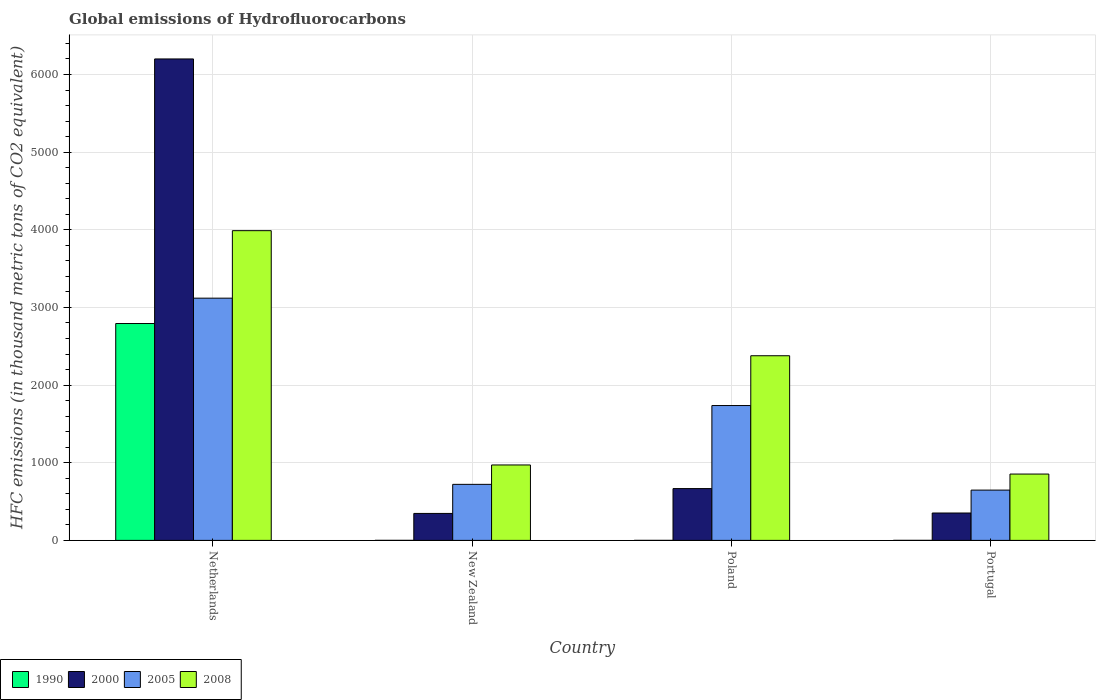How many groups of bars are there?
Ensure brevity in your answer.  4. Are the number of bars per tick equal to the number of legend labels?
Your response must be concise. Yes. Are the number of bars on each tick of the X-axis equal?
Make the answer very short. Yes. How many bars are there on the 1st tick from the left?
Give a very brief answer. 4. How many bars are there on the 4th tick from the right?
Keep it short and to the point. 4. What is the label of the 2nd group of bars from the left?
Provide a short and direct response. New Zealand. Across all countries, what is the maximum global emissions of Hydrofluorocarbons in 2005?
Ensure brevity in your answer.  3119.5. Across all countries, what is the minimum global emissions of Hydrofluorocarbons in 1990?
Keep it short and to the point. 0.1. In which country was the global emissions of Hydrofluorocarbons in 2005 maximum?
Offer a terse response. Netherlands. In which country was the global emissions of Hydrofluorocarbons in 1990 minimum?
Keep it short and to the point. Poland. What is the total global emissions of Hydrofluorocarbons in 2000 in the graph?
Ensure brevity in your answer.  7567.6. What is the difference between the global emissions of Hydrofluorocarbons in 2000 in Poland and that in Portugal?
Your answer should be compact. 314.5. What is the difference between the global emissions of Hydrofluorocarbons in 2008 in New Zealand and the global emissions of Hydrofluorocarbons in 1990 in Netherlands?
Provide a short and direct response. -1821.5. What is the average global emissions of Hydrofluorocarbons in 1990 per country?
Make the answer very short. 698.35. What is the difference between the global emissions of Hydrofluorocarbons of/in 2005 and global emissions of Hydrofluorocarbons of/in 2008 in Poland?
Give a very brief answer. -641.3. What is the ratio of the global emissions of Hydrofluorocarbons in 2005 in New Zealand to that in Portugal?
Offer a very short reply. 1.11. Is the difference between the global emissions of Hydrofluorocarbons in 2005 in New Zealand and Poland greater than the difference between the global emissions of Hydrofluorocarbons in 2008 in New Zealand and Poland?
Provide a succinct answer. Yes. What is the difference between the highest and the second highest global emissions of Hydrofluorocarbons in 2008?
Keep it short and to the point. 1406.6. What is the difference between the highest and the lowest global emissions of Hydrofluorocarbons in 1990?
Your answer should be very brief. 2792.8. Is it the case that in every country, the sum of the global emissions of Hydrofluorocarbons in 2008 and global emissions of Hydrofluorocarbons in 2000 is greater than the sum of global emissions of Hydrofluorocarbons in 1990 and global emissions of Hydrofluorocarbons in 2005?
Offer a very short reply. No. What does the 4th bar from the left in Netherlands represents?
Keep it short and to the point. 2008. Are the values on the major ticks of Y-axis written in scientific E-notation?
Your answer should be very brief. No. Does the graph contain any zero values?
Keep it short and to the point. No. How are the legend labels stacked?
Make the answer very short. Horizontal. What is the title of the graph?
Give a very brief answer. Global emissions of Hydrofluorocarbons. Does "1966" appear as one of the legend labels in the graph?
Offer a very short reply. No. What is the label or title of the X-axis?
Your response must be concise. Country. What is the label or title of the Y-axis?
Offer a very short reply. HFC emissions (in thousand metric tons of CO2 equivalent). What is the HFC emissions (in thousand metric tons of CO2 equivalent) of 1990 in Netherlands?
Keep it short and to the point. 2792.9. What is the HFC emissions (in thousand metric tons of CO2 equivalent) of 2000 in Netherlands?
Your response must be concise. 6200.4. What is the HFC emissions (in thousand metric tons of CO2 equivalent) of 2005 in Netherlands?
Offer a terse response. 3119.5. What is the HFC emissions (in thousand metric tons of CO2 equivalent) of 2008 in Netherlands?
Provide a succinct answer. 3988.8. What is the HFC emissions (in thousand metric tons of CO2 equivalent) in 2000 in New Zealand?
Provide a succinct answer. 347.3. What is the HFC emissions (in thousand metric tons of CO2 equivalent) of 2005 in New Zealand?
Offer a terse response. 721.7. What is the HFC emissions (in thousand metric tons of CO2 equivalent) of 2008 in New Zealand?
Your answer should be compact. 971.4. What is the HFC emissions (in thousand metric tons of CO2 equivalent) of 2000 in Poland?
Your response must be concise. 667.2. What is the HFC emissions (in thousand metric tons of CO2 equivalent) in 2005 in Poland?
Offer a very short reply. 1736.7. What is the HFC emissions (in thousand metric tons of CO2 equivalent) of 2008 in Poland?
Offer a very short reply. 2378. What is the HFC emissions (in thousand metric tons of CO2 equivalent) of 2000 in Portugal?
Your answer should be very brief. 352.7. What is the HFC emissions (in thousand metric tons of CO2 equivalent) in 2005 in Portugal?
Your answer should be compact. 647.7. What is the HFC emissions (in thousand metric tons of CO2 equivalent) in 2008 in Portugal?
Provide a short and direct response. 854.4. Across all countries, what is the maximum HFC emissions (in thousand metric tons of CO2 equivalent) of 1990?
Offer a terse response. 2792.9. Across all countries, what is the maximum HFC emissions (in thousand metric tons of CO2 equivalent) in 2000?
Your response must be concise. 6200.4. Across all countries, what is the maximum HFC emissions (in thousand metric tons of CO2 equivalent) in 2005?
Offer a very short reply. 3119.5. Across all countries, what is the maximum HFC emissions (in thousand metric tons of CO2 equivalent) in 2008?
Your response must be concise. 3988.8. Across all countries, what is the minimum HFC emissions (in thousand metric tons of CO2 equivalent) of 1990?
Provide a succinct answer. 0.1. Across all countries, what is the minimum HFC emissions (in thousand metric tons of CO2 equivalent) in 2000?
Your answer should be compact. 347.3. Across all countries, what is the minimum HFC emissions (in thousand metric tons of CO2 equivalent) of 2005?
Give a very brief answer. 647.7. Across all countries, what is the minimum HFC emissions (in thousand metric tons of CO2 equivalent) in 2008?
Provide a short and direct response. 854.4. What is the total HFC emissions (in thousand metric tons of CO2 equivalent) of 1990 in the graph?
Make the answer very short. 2793.4. What is the total HFC emissions (in thousand metric tons of CO2 equivalent) of 2000 in the graph?
Provide a succinct answer. 7567.6. What is the total HFC emissions (in thousand metric tons of CO2 equivalent) in 2005 in the graph?
Your response must be concise. 6225.6. What is the total HFC emissions (in thousand metric tons of CO2 equivalent) of 2008 in the graph?
Your answer should be very brief. 8192.6. What is the difference between the HFC emissions (in thousand metric tons of CO2 equivalent) of 1990 in Netherlands and that in New Zealand?
Make the answer very short. 2792.7. What is the difference between the HFC emissions (in thousand metric tons of CO2 equivalent) in 2000 in Netherlands and that in New Zealand?
Keep it short and to the point. 5853.1. What is the difference between the HFC emissions (in thousand metric tons of CO2 equivalent) of 2005 in Netherlands and that in New Zealand?
Your response must be concise. 2397.8. What is the difference between the HFC emissions (in thousand metric tons of CO2 equivalent) of 2008 in Netherlands and that in New Zealand?
Your response must be concise. 3017.4. What is the difference between the HFC emissions (in thousand metric tons of CO2 equivalent) of 1990 in Netherlands and that in Poland?
Offer a terse response. 2792.8. What is the difference between the HFC emissions (in thousand metric tons of CO2 equivalent) in 2000 in Netherlands and that in Poland?
Make the answer very short. 5533.2. What is the difference between the HFC emissions (in thousand metric tons of CO2 equivalent) in 2005 in Netherlands and that in Poland?
Your answer should be compact. 1382.8. What is the difference between the HFC emissions (in thousand metric tons of CO2 equivalent) in 2008 in Netherlands and that in Poland?
Offer a very short reply. 1610.8. What is the difference between the HFC emissions (in thousand metric tons of CO2 equivalent) in 1990 in Netherlands and that in Portugal?
Your answer should be very brief. 2792.7. What is the difference between the HFC emissions (in thousand metric tons of CO2 equivalent) of 2000 in Netherlands and that in Portugal?
Ensure brevity in your answer.  5847.7. What is the difference between the HFC emissions (in thousand metric tons of CO2 equivalent) in 2005 in Netherlands and that in Portugal?
Give a very brief answer. 2471.8. What is the difference between the HFC emissions (in thousand metric tons of CO2 equivalent) of 2008 in Netherlands and that in Portugal?
Give a very brief answer. 3134.4. What is the difference between the HFC emissions (in thousand metric tons of CO2 equivalent) in 2000 in New Zealand and that in Poland?
Your answer should be very brief. -319.9. What is the difference between the HFC emissions (in thousand metric tons of CO2 equivalent) in 2005 in New Zealand and that in Poland?
Keep it short and to the point. -1015. What is the difference between the HFC emissions (in thousand metric tons of CO2 equivalent) of 2008 in New Zealand and that in Poland?
Your answer should be very brief. -1406.6. What is the difference between the HFC emissions (in thousand metric tons of CO2 equivalent) of 1990 in New Zealand and that in Portugal?
Your response must be concise. 0. What is the difference between the HFC emissions (in thousand metric tons of CO2 equivalent) of 2000 in New Zealand and that in Portugal?
Your answer should be compact. -5.4. What is the difference between the HFC emissions (in thousand metric tons of CO2 equivalent) of 2008 in New Zealand and that in Portugal?
Provide a short and direct response. 117. What is the difference between the HFC emissions (in thousand metric tons of CO2 equivalent) of 2000 in Poland and that in Portugal?
Your response must be concise. 314.5. What is the difference between the HFC emissions (in thousand metric tons of CO2 equivalent) of 2005 in Poland and that in Portugal?
Your response must be concise. 1089. What is the difference between the HFC emissions (in thousand metric tons of CO2 equivalent) in 2008 in Poland and that in Portugal?
Keep it short and to the point. 1523.6. What is the difference between the HFC emissions (in thousand metric tons of CO2 equivalent) in 1990 in Netherlands and the HFC emissions (in thousand metric tons of CO2 equivalent) in 2000 in New Zealand?
Offer a very short reply. 2445.6. What is the difference between the HFC emissions (in thousand metric tons of CO2 equivalent) of 1990 in Netherlands and the HFC emissions (in thousand metric tons of CO2 equivalent) of 2005 in New Zealand?
Provide a succinct answer. 2071.2. What is the difference between the HFC emissions (in thousand metric tons of CO2 equivalent) of 1990 in Netherlands and the HFC emissions (in thousand metric tons of CO2 equivalent) of 2008 in New Zealand?
Keep it short and to the point. 1821.5. What is the difference between the HFC emissions (in thousand metric tons of CO2 equivalent) of 2000 in Netherlands and the HFC emissions (in thousand metric tons of CO2 equivalent) of 2005 in New Zealand?
Keep it short and to the point. 5478.7. What is the difference between the HFC emissions (in thousand metric tons of CO2 equivalent) of 2000 in Netherlands and the HFC emissions (in thousand metric tons of CO2 equivalent) of 2008 in New Zealand?
Your answer should be compact. 5229. What is the difference between the HFC emissions (in thousand metric tons of CO2 equivalent) of 2005 in Netherlands and the HFC emissions (in thousand metric tons of CO2 equivalent) of 2008 in New Zealand?
Ensure brevity in your answer.  2148.1. What is the difference between the HFC emissions (in thousand metric tons of CO2 equivalent) in 1990 in Netherlands and the HFC emissions (in thousand metric tons of CO2 equivalent) in 2000 in Poland?
Your response must be concise. 2125.7. What is the difference between the HFC emissions (in thousand metric tons of CO2 equivalent) of 1990 in Netherlands and the HFC emissions (in thousand metric tons of CO2 equivalent) of 2005 in Poland?
Give a very brief answer. 1056.2. What is the difference between the HFC emissions (in thousand metric tons of CO2 equivalent) in 1990 in Netherlands and the HFC emissions (in thousand metric tons of CO2 equivalent) in 2008 in Poland?
Your answer should be very brief. 414.9. What is the difference between the HFC emissions (in thousand metric tons of CO2 equivalent) of 2000 in Netherlands and the HFC emissions (in thousand metric tons of CO2 equivalent) of 2005 in Poland?
Keep it short and to the point. 4463.7. What is the difference between the HFC emissions (in thousand metric tons of CO2 equivalent) in 2000 in Netherlands and the HFC emissions (in thousand metric tons of CO2 equivalent) in 2008 in Poland?
Keep it short and to the point. 3822.4. What is the difference between the HFC emissions (in thousand metric tons of CO2 equivalent) of 2005 in Netherlands and the HFC emissions (in thousand metric tons of CO2 equivalent) of 2008 in Poland?
Offer a terse response. 741.5. What is the difference between the HFC emissions (in thousand metric tons of CO2 equivalent) of 1990 in Netherlands and the HFC emissions (in thousand metric tons of CO2 equivalent) of 2000 in Portugal?
Make the answer very short. 2440.2. What is the difference between the HFC emissions (in thousand metric tons of CO2 equivalent) in 1990 in Netherlands and the HFC emissions (in thousand metric tons of CO2 equivalent) in 2005 in Portugal?
Your answer should be very brief. 2145.2. What is the difference between the HFC emissions (in thousand metric tons of CO2 equivalent) of 1990 in Netherlands and the HFC emissions (in thousand metric tons of CO2 equivalent) of 2008 in Portugal?
Keep it short and to the point. 1938.5. What is the difference between the HFC emissions (in thousand metric tons of CO2 equivalent) in 2000 in Netherlands and the HFC emissions (in thousand metric tons of CO2 equivalent) in 2005 in Portugal?
Offer a terse response. 5552.7. What is the difference between the HFC emissions (in thousand metric tons of CO2 equivalent) in 2000 in Netherlands and the HFC emissions (in thousand metric tons of CO2 equivalent) in 2008 in Portugal?
Make the answer very short. 5346. What is the difference between the HFC emissions (in thousand metric tons of CO2 equivalent) in 2005 in Netherlands and the HFC emissions (in thousand metric tons of CO2 equivalent) in 2008 in Portugal?
Ensure brevity in your answer.  2265.1. What is the difference between the HFC emissions (in thousand metric tons of CO2 equivalent) in 1990 in New Zealand and the HFC emissions (in thousand metric tons of CO2 equivalent) in 2000 in Poland?
Provide a short and direct response. -667. What is the difference between the HFC emissions (in thousand metric tons of CO2 equivalent) of 1990 in New Zealand and the HFC emissions (in thousand metric tons of CO2 equivalent) of 2005 in Poland?
Provide a short and direct response. -1736.5. What is the difference between the HFC emissions (in thousand metric tons of CO2 equivalent) in 1990 in New Zealand and the HFC emissions (in thousand metric tons of CO2 equivalent) in 2008 in Poland?
Keep it short and to the point. -2377.8. What is the difference between the HFC emissions (in thousand metric tons of CO2 equivalent) of 2000 in New Zealand and the HFC emissions (in thousand metric tons of CO2 equivalent) of 2005 in Poland?
Make the answer very short. -1389.4. What is the difference between the HFC emissions (in thousand metric tons of CO2 equivalent) in 2000 in New Zealand and the HFC emissions (in thousand metric tons of CO2 equivalent) in 2008 in Poland?
Provide a short and direct response. -2030.7. What is the difference between the HFC emissions (in thousand metric tons of CO2 equivalent) of 2005 in New Zealand and the HFC emissions (in thousand metric tons of CO2 equivalent) of 2008 in Poland?
Keep it short and to the point. -1656.3. What is the difference between the HFC emissions (in thousand metric tons of CO2 equivalent) of 1990 in New Zealand and the HFC emissions (in thousand metric tons of CO2 equivalent) of 2000 in Portugal?
Ensure brevity in your answer.  -352.5. What is the difference between the HFC emissions (in thousand metric tons of CO2 equivalent) of 1990 in New Zealand and the HFC emissions (in thousand metric tons of CO2 equivalent) of 2005 in Portugal?
Provide a short and direct response. -647.5. What is the difference between the HFC emissions (in thousand metric tons of CO2 equivalent) in 1990 in New Zealand and the HFC emissions (in thousand metric tons of CO2 equivalent) in 2008 in Portugal?
Provide a succinct answer. -854.2. What is the difference between the HFC emissions (in thousand metric tons of CO2 equivalent) in 2000 in New Zealand and the HFC emissions (in thousand metric tons of CO2 equivalent) in 2005 in Portugal?
Offer a very short reply. -300.4. What is the difference between the HFC emissions (in thousand metric tons of CO2 equivalent) in 2000 in New Zealand and the HFC emissions (in thousand metric tons of CO2 equivalent) in 2008 in Portugal?
Give a very brief answer. -507.1. What is the difference between the HFC emissions (in thousand metric tons of CO2 equivalent) in 2005 in New Zealand and the HFC emissions (in thousand metric tons of CO2 equivalent) in 2008 in Portugal?
Give a very brief answer. -132.7. What is the difference between the HFC emissions (in thousand metric tons of CO2 equivalent) of 1990 in Poland and the HFC emissions (in thousand metric tons of CO2 equivalent) of 2000 in Portugal?
Give a very brief answer. -352.6. What is the difference between the HFC emissions (in thousand metric tons of CO2 equivalent) of 1990 in Poland and the HFC emissions (in thousand metric tons of CO2 equivalent) of 2005 in Portugal?
Your answer should be compact. -647.6. What is the difference between the HFC emissions (in thousand metric tons of CO2 equivalent) in 1990 in Poland and the HFC emissions (in thousand metric tons of CO2 equivalent) in 2008 in Portugal?
Offer a very short reply. -854.3. What is the difference between the HFC emissions (in thousand metric tons of CO2 equivalent) in 2000 in Poland and the HFC emissions (in thousand metric tons of CO2 equivalent) in 2005 in Portugal?
Provide a succinct answer. 19.5. What is the difference between the HFC emissions (in thousand metric tons of CO2 equivalent) in 2000 in Poland and the HFC emissions (in thousand metric tons of CO2 equivalent) in 2008 in Portugal?
Your response must be concise. -187.2. What is the difference between the HFC emissions (in thousand metric tons of CO2 equivalent) of 2005 in Poland and the HFC emissions (in thousand metric tons of CO2 equivalent) of 2008 in Portugal?
Offer a terse response. 882.3. What is the average HFC emissions (in thousand metric tons of CO2 equivalent) of 1990 per country?
Your answer should be compact. 698.35. What is the average HFC emissions (in thousand metric tons of CO2 equivalent) in 2000 per country?
Your answer should be very brief. 1891.9. What is the average HFC emissions (in thousand metric tons of CO2 equivalent) in 2005 per country?
Give a very brief answer. 1556.4. What is the average HFC emissions (in thousand metric tons of CO2 equivalent) in 2008 per country?
Your response must be concise. 2048.15. What is the difference between the HFC emissions (in thousand metric tons of CO2 equivalent) in 1990 and HFC emissions (in thousand metric tons of CO2 equivalent) in 2000 in Netherlands?
Offer a terse response. -3407.5. What is the difference between the HFC emissions (in thousand metric tons of CO2 equivalent) of 1990 and HFC emissions (in thousand metric tons of CO2 equivalent) of 2005 in Netherlands?
Ensure brevity in your answer.  -326.6. What is the difference between the HFC emissions (in thousand metric tons of CO2 equivalent) in 1990 and HFC emissions (in thousand metric tons of CO2 equivalent) in 2008 in Netherlands?
Ensure brevity in your answer.  -1195.9. What is the difference between the HFC emissions (in thousand metric tons of CO2 equivalent) in 2000 and HFC emissions (in thousand metric tons of CO2 equivalent) in 2005 in Netherlands?
Offer a very short reply. 3080.9. What is the difference between the HFC emissions (in thousand metric tons of CO2 equivalent) in 2000 and HFC emissions (in thousand metric tons of CO2 equivalent) in 2008 in Netherlands?
Your answer should be very brief. 2211.6. What is the difference between the HFC emissions (in thousand metric tons of CO2 equivalent) of 2005 and HFC emissions (in thousand metric tons of CO2 equivalent) of 2008 in Netherlands?
Offer a very short reply. -869.3. What is the difference between the HFC emissions (in thousand metric tons of CO2 equivalent) in 1990 and HFC emissions (in thousand metric tons of CO2 equivalent) in 2000 in New Zealand?
Provide a short and direct response. -347.1. What is the difference between the HFC emissions (in thousand metric tons of CO2 equivalent) in 1990 and HFC emissions (in thousand metric tons of CO2 equivalent) in 2005 in New Zealand?
Your answer should be very brief. -721.5. What is the difference between the HFC emissions (in thousand metric tons of CO2 equivalent) of 1990 and HFC emissions (in thousand metric tons of CO2 equivalent) of 2008 in New Zealand?
Offer a terse response. -971.2. What is the difference between the HFC emissions (in thousand metric tons of CO2 equivalent) in 2000 and HFC emissions (in thousand metric tons of CO2 equivalent) in 2005 in New Zealand?
Your response must be concise. -374.4. What is the difference between the HFC emissions (in thousand metric tons of CO2 equivalent) in 2000 and HFC emissions (in thousand metric tons of CO2 equivalent) in 2008 in New Zealand?
Provide a succinct answer. -624.1. What is the difference between the HFC emissions (in thousand metric tons of CO2 equivalent) of 2005 and HFC emissions (in thousand metric tons of CO2 equivalent) of 2008 in New Zealand?
Give a very brief answer. -249.7. What is the difference between the HFC emissions (in thousand metric tons of CO2 equivalent) of 1990 and HFC emissions (in thousand metric tons of CO2 equivalent) of 2000 in Poland?
Give a very brief answer. -667.1. What is the difference between the HFC emissions (in thousand metric tons of CO2 equivalent) of 1990 and HFC emissions (in thousand metric tons of CO2 equivalent) of 2005 in Poland?
Give a very brief answer. -1736.6. What is the difference between the HFC emissions (in thousand metric tons of CO2 equivalent) in 1990 and HFC emissions (in thousand metric tons of CO2 equivalent) in 2008 in Poland?
Offer a terse response. -2377.9. What is the difference between the HFC emissions (in thousand metric tons of CO2 equivalent) of 2000 and HFC emissions (in thousand metric tons of CO2 equivalent) of 2005 in Poland?
Your answer should be compact. -1069.5. What is the difference between the HFC emissions (in thousand metric tons of CO2 equivalent) of 2000 and HFC emissions (in thousand metric tons of CO2 equivalent) of 2008 in Poland?
Your answer should be compact. -1710.8. What is the difference between the HFC emissions (in thousand metric tons of CO2 equivalent) of 2005 and HFC emissions (in thousand metric tons of CO2 equivalent) of 2008 in Poland?
Give a very brief answer. -641.3. What is the difference between the HFC emissions (in thousand metric tons of CO2 equivalent) of 1990 and HFC emissions (in thousand metric tons of CO2 equivalent) of 2000 in Portugal?
Your answer should be compact. -352.5. What is the difference between the HFC emissions (in thousand metric tons of CO2 equivalent) in 1990 and HFC emissions (in thousand metric tons of CO2 equivalent) in 2005 in Portugal?
Provide a short and direct response. -647.5. What is the difference between the HFC emissions (in thousand metric tons of CO2 equivalent) in 1990 and HFC emissions (in thousand metric tons of CO2 equivalent) in 2008 in Portugal?
Provide a short and direct response. -854.2. What is the difference between the HFC emissions (in thousand metric tons of CO2 equivalent) in 2000 and HFC emissions (in thousand metric tons of CO2 equivalent) in 2005 in Portugal?
Your response must be concise. -295. What is the difference between the HFC emissions (in thousand metric tons of CO2 equivalent) of 2000 and HFC emissions (in thousand metric tons of CO2 equivalent) of 2008 in Portugal?
Make the answer very short. -501.7. What is the difference between the HFC emissions (in thousand metric tons of CO2 equivalent) of 2005 and HFC emissions (in thousand metric tons of CO2 equivalent) of 2008 in Portugal?
Make the answer very short. -206.7. What is the ratio of the HFC emissions (in thousand metric tons of CO2 equivalent) of 1990 in Netherlands to that in New Zealand?
Give a very brief answer. 1.40e+04. What is the ratio of the HFC emissions (in thousand metric tons of CO2 equivalent) of 2000 in Netherlands to that in New Zealand?
Offer a very short reply. 17.85. What is the ratio of the HFC emissions (in thousand metric tons of CO2 equivalent) of 2005 in Netherlands to that in New Zealand?
Provide a succinct answer. 4.32. What is the ratio of the HFC emissions (in thousand metric tons of CO2 equivalent) of 2008 in Netherlands to that in New Zealand?
Your response must be concise. 4.11. What is the ratio of the HFC emissions (in thousand metric tons of CO2 equivalent) in 1990 in Netherlands to that in Poland?
Offer a very short reply. 2.79e+04. What is the ratio of the HFC emissions (in thousand metric tons of CO2 equivalent) in 2000 in Netherlands to that in Poland?
Ensure brevity in your answer.  9.29. What is the ratio of the HFC emissions (in thousand metric tons of CO2 equivalent) of 2005 in Netherlands to that in Poland?
Offer a terse response. 1.8. What is the ratio of the HFC emissions (in thousand metric tons of CO2 equivalent) of 2008 in Netherlands to that in Poland?
Your response must be concise. 1.68. What is the ratio of the HFC emissions (in thousand metric tons of CO2 equivalent) in 1990 in Netherlands to that in Portugal?
Give a very brief answer. 1.40e+04. What is the ratio of the HFC emissions (in thousand metric tons of CO2 equivalent) in 2000 in Netherlands to that in Portugal?
Offer a terse response. 17.58. What is the ratio of the HFC emissions (in thousand metric tons of CO2 equivalent) in 2005 in Netherlands to that in Portugal?
Ensure brevity in your answer.  4.82. What is the ratio of the HFC emissions (in thousand metric tons of CO2 equivalent) in 2008 in Netherlands to that in Portugal?
Your response must be concise. 4.67. What is the ratio of the HFC emissions (in thousand metric tons of CO2 equivalent) in 2000 in New Zealand to that in Poland?
Your response must be concise. 0.52. What is the ratio of the HFC emissions (in thousand metric tons of CO2 equivalent) of 2005 in New Zealand to that in Poland?
Keep it short and to the point. 0.42. What is the ratio of the HFC emissions (in thousand metric tons of CO2 equivalent) of 2008 in New Zealand to that in Poland?
Your response must be concise. 0.41. What is the ratio of the HFC emissions (in thousand metric tons of CO2 equivalent) in 2000 in New Zealand to that in Portugal?
Your response must be concise. 0.98. What is the ratio of the HFC emissions (in thousand metric tons of CO2 equivalent) in 2005 in New Zealand to that in Portugal?
Make the answer very short. 1.11. What is the ratio of the HFC emissions (in thousand metric tons of CO2 equivalent) of 2008 in New Zealand to that in Portugal?
Your answer should be very brief. 1.14. What is the ratio of the HFC emissions (in thousand metric tons of CO2 equivalent) of 1990 in Poland to that in Portugal?
Make the answer very short. 0.5. What is the ratio of the HFC emissions (in thousand metric tons of CO2 equivalent) in 2000 in Poland to that in Portugal?
Offer a terse response. 1.89. What is the ratio of the HFC emissions (in thousand metric tons of CO2 equivalent) in 2005 in Poland to that in Portugal?
Make the answer very short. 2.68. What is the ratio of the HFC emissions (in thousand metric tons of CO2 equivalent) of 2008 in Poland to that in Portugal?
Make the answer very short. 2.78. What is the difference between the highest and the second highest HFC emissions (in thousand metric tons of CO2 equivalent) of 1990?
Provide a succinct answer. 2792.7. What is the difference between the highest and the second highest HFC emissions (in thousand metric tons of CO2 equivalent) of 2000?
Give a very brief answer. 5533.2. What is the difference between the highest and the second highest HFC emissions (in thousand metric tons of CO2 equivalent) of 2005?
Offer a terse response. 1382.8. What is the difference between the highest and the second highest HFC emissions (in thousand metric tons of CO2 equivalent) of 2008?
Ensure brevity in your answer.  1610.8. What is the difference between the highest and the lowest HFC emissions (in thousand metric tons of CO2 equivalent) in 1990?
Your response must be concise. 2792.8. What is the difference between the highest and the lowest HFC emissions (in thousand metric tons of CO2 equivalent) of 2000?
Offer a very short reply. 5853.1. What is the difference between the highest and the lowest HFC emissions (in thousand metric tons of CO2 equivalent) of 2005?
Your answer should be compact. 2471.8. What is the difference between the highest and the lowest HFC emissions (in thousand metric tons of CO2 equivalent) in 2008?
Offer a terse response. 3134.4. 